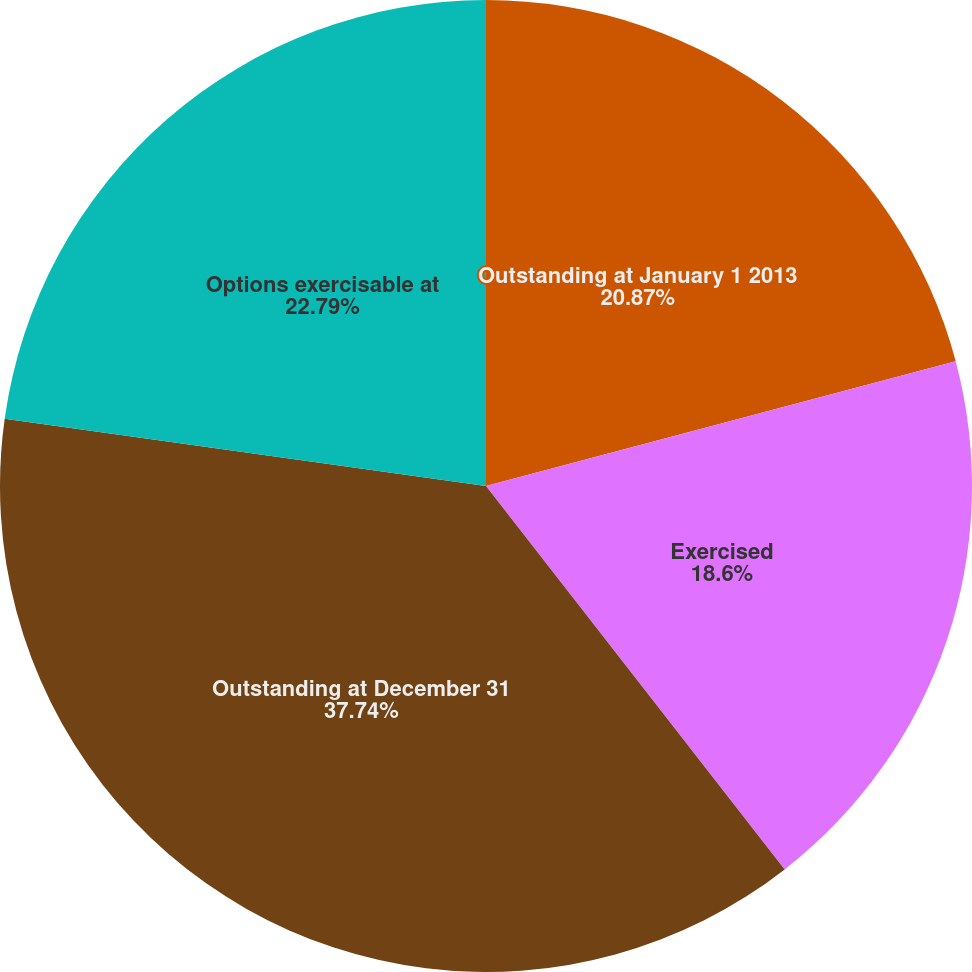Convert chart to OTSL. <chart><loc_0><loc_0><loc_500><loc_500><pie_chart><fcel>Outstanding at January 1 2013<fcel>Exercised<fcel>Outstanding at December 31<fcel>Options exercisable at<nl><fcel>20.87%<fcel>18.6%<fcel>37.75%<fcel>22.79%<nl></chart> 